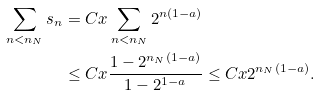Convert formula to latex. <formula><loc_0><loc_0><loc_500><loc_500>\sum _ { n < n _ { N } } s _ { n } & = C x \sum _ { n < n _ { N } } 2 ^ { n ( 1 - a ) } \\ & \leq C x \frac { 1 - 2 ^ { n _ { N } ( 1 - a ) } } { 1 - 2 ^ { 1 - a } } \leq C x 2 ^ { n _ { N } ( 1 - a ) } .</formula> 